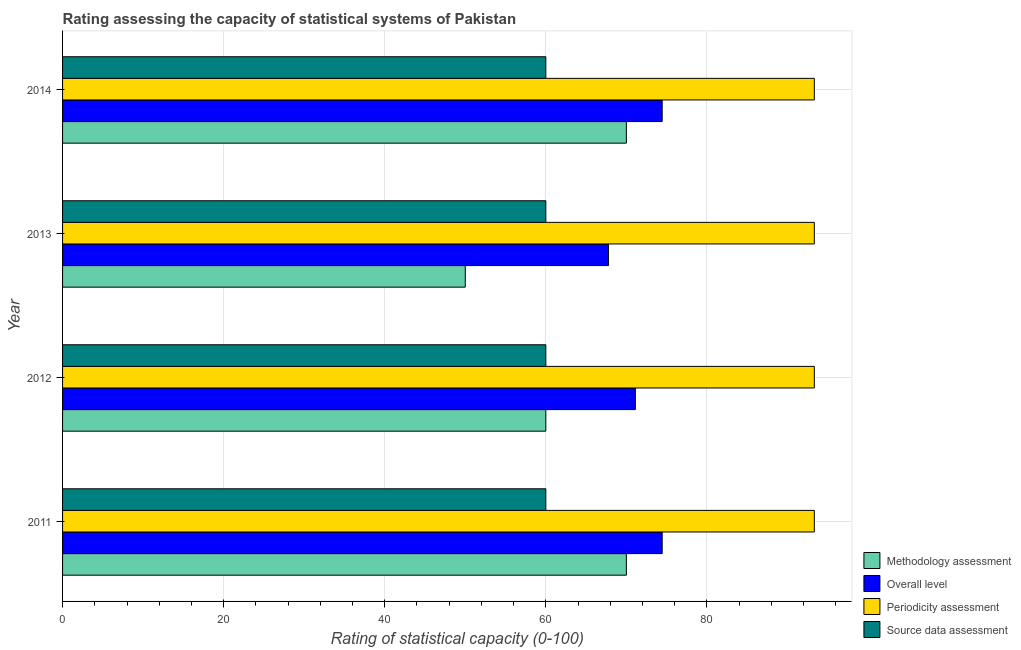How many bars are there on the 2nd tick from the top?
Provide a short and direct response. 4. In how many cases, is the number of bars for a given year not equal to the number of legend labels?
Give a very brief answer. 0. What is the source data assessment rating in 2012?
Offer a terse response. 60. Across all years, what is the maximum source data assessment rating?
Provide a succinct answer. 60. Across all years, what is the minimum periodicity assessment rating?
Your response must be concise. 93.33. In which year was the methodology assessment rating maximum?
Ensure brevity in your answer.  2011. In which year was the methodology assessment rating minimum?
Give a very brief answer. 2013. What is the total source data assessment rating in the graph?
Ensure brevity in your answer.  240. What is the difference between the overall level rating in 2013 and that in 2014?
Ensure brevity in your answer.  -6.67. What is the difference between the periodicity assessment rating in 2012 and the methodology assessment rating in 2014?
Your response must be concise. 23.33. What is the average overall level rating per year?
Keep it short and to the point. 71.94. In the year 2013, what is the difference between the overall level rating and methodology assessment rating?
Make the answer very short. 17.78. What is the ratio of the periodicity assessment rating in 2011 to that in 2013?
Your answer should be very brief. 1. Is the periodicity assessment rating in 2011 less than that in 2012?
Your answer should be very brief. No. What is the difference between the highest and the second highest methodology assessment rating?
Make the answer very short. 0. What is the difference between the highest and the lowest methodology assessment rating?
Your answer should be very brief. 20. In how many years, is the periodicity assessment rating greater than the average periodicity assessment rating taken over all years?
Your answer should be very brief. 2. Is the sum of the periodicity assessment rating in 2011 and 2013 greater than the maximum methodology assessment rating across all years?
Give a very brief answer. Yes. What does the 1st bar from the top in 2011 represents?
Give a very brief answer. Source data assessment. What does the 4th bar from the bottom in 2012 represents?
Your answer should be compact. Source data assessment. How many bars are there?
Provide a succinct answer. 16. How many years are there in the graph?
Your answer should be compact. 4. Are the values on the major ticks of X-axis written in scientific E-notation?
Ensure brevity in your answer.  No. Does the graph contain any zero values?
Ensure brevity in your answer.  No. Where does the legend appear in the graph?
Your response must be concise. Bottom right. What is the title of the graph?
Give a very brief answer. Rating assessing the capacity of statistical systems of Pakistan. Does "Labor Taxes" appear as one of the legend labels in the graph?
Provide a short and direct response. No. What is the label or title of the X-axis?
Your response must be concise. Rating of statistical capacity (0-100). What is the Rating of statistical capacity (0-100) in Overall level in 2011?
Your answer should be very brief. 74.44. What is the Rating of statistical capacity (0-100) in Periodicity assessment in 2011?
Provide a short and direct response. 93.33. What is the Rating of statistical capacity (0-100) of Methodology assessment in 2012?
Make the answer very short. 60. What is the Rating of statistical capacity (0-100) in Overall level in 2012?
Give a very brief answer. 71.11. What is the Rating of statistical capacity (0-100) of Periodicity assessment in 2012?
Offer a very short reply. 93.33. What is the Rating of statistical capacity (0-100) in Overall level in 2013?
Your answer should be very brief. 67.78. What is the Rating of statistical capacity (0-100) of Periodicity assessment in 2013?
Keep it short and to the point. 93.33. What is the Rating of statistical capacity (0-100) in Overall level in 2014?
Your response must be concise. 74.44. What is the Rating of statistical capacity (0-100) in Periodicity assessment in 2014?
Provide a short and direct response. 93.33. Across all years, what is the maximum Rating of statistical capacity (0-100) of Methodology assessment?
Provide a succinct answer. 70. Across all years, what is the maximum Rating of statistical capacity (0-100) in Overall level?
Give a very brief answer. 74.44. Across all years, what is the maximum Rating of statistical capacity (0-100) of Periodicity assessment?
Your response must be concise. 93.33. Across all years, what is the minimum Rating of statistical capacity (0-100) in Overall level?
Provide a short and direct response. 67.78. Across all years, what is the minimum Rating of statistical capacity (0-100) in Periodicity assessment?
Make the answer very short. 93.33. What is the total Rating of statistical capacity (0-100) of Methodology assessment in the graph?
Your response must be concise. 250. What is the total Rating of statistical capacity (0-100) in Overall level in the graph?
Keep it short and to the point. 287.78. What is the total Rating of statistical capacity (0-100) of Periodicity assessment in the graph?
Give a very brief answer. 373.33. What is the total Rating of statistical capacity (0-100) in Source data assessment in the graph?
Make the answer very short. 240. What is the difference between the Rating of statistical capacity (0-100) of Overall level in 2011 and that in 2013?
Make the answer very short. 6.67. What is the difference between the Rating of statistical capacity (0-100) in Periodicity assessment in 2011 and that in 2013?
Your response must be concise. -0. What is the difference between the Rating of statistical capacity (0-100) in Methodology assessment in 2011 and that in 2014?
Ensure brevity in your answer.  0. What is the difference between the Rating of statistical capacity (0-100) of Overall level in 2011 and that in 2014?
Offer a very short reply. 0. What is the difference between the Rating of statistical capacity (0-100) in Periodicity assessment in 2011 and that in 2014?
Provide a short and direct response. -0. What is the difference between the Rating of statistical capacity (0-100) in Source data assessment in 2012 and that in 2013?
Keep it short and to the point. 0. What is the difference between the Rating of statistical capacity (0-100) in Methodology assessment in 2012 and that in 2014?
Keep it short and to the point. -10. What is the difference between the Rating of statistical capacity (0-100) in Overall level in 2012 and that in 2014?
Offer a terse response. -3.33. What is the difference between the Rating of statistical capacity (0-100) in Periodicity assessment in 2012 and that in 2014?
Make the answer very short. -0. What is the difference between the Rating of statistical capacity (0-100) in Overall level in 2013 and that in 2014?
Offer a very short reply. -6.67. What is the difference between the Rating of statistical capacity (0-100) of Methodology assessment in 2011 and the Rating of statistical capacity (0-100) of Overall level in 2012?
Offer a very short reply. -1.11. What is the difference between the Rating of statistical capacity (0-100) in Methodology assessment in 2011 and the Rating of statistical capacity (0-100) in Periodicity assessment in 2012?
Provide a succinct answer. -23.33. What is the difference between the Rating of statistical capacity (0-100) in Methodology assessment in 2011 and the Rating of statistical capacity (0-100) in Source data assessment in 2012?
Keep it short and to the point. 10. What is the difference between the Rating of statistical capacity (0-100) of Overall level in 2011 and the Rating of statistical capacity (0-100) of Periodicity assessment in 2012?
Ensure brevity in your answer.  -18.89. What is the difference between the Rating of statistical capacity (0-100) in Overall level in 2011 and the Rating of statistical capacity (0-100) in Source data assessment in 2012?
Ensure brevity in your answer.  14.44. What is the difference between the Rating of statistical capacity (0-100) of Periodicity assessment in 2011 and the Rating of statistical capacity (0-100) of Source data assessment in 2012?
Ensure brevity in your answer.  33.33. What is the difference between the Rating of statistical capacity (0-100) in Methodology assessment in 2011 and the Rating of statistical capacity (0-100) in Overall level in 2013?
Provide a succinct answer. 2.22. What is the difference between the Rating of statistical capacity (0-100) of Methodology assessment in 2011 and the Rating of statistical capacity (0-100) of Periodicity assessment in 2013?
Ensure brevity in your answer.  -23.33. What is the difference between the Rating of statistical capacity (0-100) in Overall level in 2011 and the Rating of statistical capacity (0-100) in Periodicity assessment in 2013?
Give a very brief answer. -18.89. What is the difference between the Rating of statistical capacity (0-100) in Overall level in 2011 and the Rating of statistical capacity (0-100) in Source data assessment in 2013?
Your answer should be compact. 14.44. What is the difference between the Rating of statistical capacity (0-100) of Periodicity assessment in 2011 and the Rating of statistical capacity (0-100) of Source data assessment in 2013?
Your answer should be compact. 33.33. What is the difference between the Rating of statistical capacity (0-100) in Methodology assessment in 2011 and the Rating of statistical capacity (0-100) in Overall level in 2014?
Offer a very short reply. -4.44. What is the difference between the Rating of statistical capacity (0-100) in Methodology assessment in 2011 and the Rating of statistical capacity (0-100) in Periodicity assessment in 2014?
Make the answer very short. -23.33. What is the difference between the Rating of statistical capacity (0-100) of Overall level in 2011 and the Rating of statistical capacity (0-100) of Periodicity assessment in 2014?
Your answer should be very brief. -18.89. What is the difference between the Rating of statistical capacity (0-100) of Overall level in 2011 and the Rating of statistical capacity (0-100) of Source data assessment in 2014?
Offer a terse response. 14.44. What is the difference between the Rating of statistical capacity (0-100) of Periodicity assessment in 2011 and the Rating of statistical capacity (0-100) of Source data assessment in 2014?
Your answer should be compact. 33.33. What is the difference between the Rating of statistical capacity (0-100) of Methodology assessment in 2012 and the Rating of statistical capacity (0-100) of Overall level in 2013?
Provide a succinct answer. -7.78. What is the difference between the Rating of statistical capacity (0-100) in Methodology assessment in 2012 and the Rating of statistical capacity (0-100) in Periodicity assessment in 2013?
Ensure brevity in your answer.  -33.33. What is the difference between the Rating of statistical capacity (0-100) of Overall level in 2012 and the Rating of statistical capacity (0-100) of Periodicity assessment in 2013?
Your answer should be very brief. -22.22. What is the difference between the Rating of statistical capacity (0-100) in Overall level in 2012 and the Rating of statistical capacity (0-100) in Source data assessment in 2013?
Keep it short and to the point. 11.11. What is the difference between the Rating of statistical capacity (0-100) of Periodicity assessment in 2012 and the Rating of statistical capacity (0-100) of Source data assessment in 2013?
Give a very brief answer. 33.33. What is the difference between the Rating of statistical capacity (0-100) in Methodology assessment in 2012 and the Rating of statistical capacity (0-100) in Overall level in 2014?
Provide a short and direct response. -14.44. What is the difference between the Rating of statistical capacity (0-100) of Methodology assessment in 2012 and the Rating of statistical capacity (0-100) of Periodicity assessment in 2014?
Your response must be concise. -33.33. What is the difference between the Rating of statistical capacity (0-100) in Overall level in 2012 and the Rating of statistical capacity (0-100) in Periodicity assessment in 2014?
Provide a short and direct response. -22.22. What is the difference between the Rating of statistical capacity (0-100) in Overall level in 2012 and the Rating of statistical capacity (0-100) in Source data assessment in 2014?
Provide a short and direct response. 11.11. What is the difference between the Rating of statistical capacity (0-100) of Periodicity assessment in 2012 and the Rating of statistical capacity (0-100) of Source data assessment in 2014?
Your answer should be compact. 33.33. What is the difference between the Rating of statistical capacity (0-100) of Methodology assessment in 2013 and the Rating of statistical capacity (0-100) of Overall level in 2014?
Offer a very short reply. -24.44. What is the difference between the Rating of statistical capacity (0-100) of Methodology assessment in 2013 and the Rating of statistical capacity (0-100) of Periodicity assessment in 2014?
Give a very brief answer. -43.33. What is the difference between the Rating of statistical capacity (0-100) in Overall level in 2013 and the Rating of statistical capacity (0-100) in Periodicity assessment in 2014?
Give a very brief answer. -25.56. What is the difference between the Rating of statistical capacity (0-100) in Overall level in 2013 and the Rating of statistical capacity (0-100) in Source data assessment in 2014?
Your answer should be very brief. 7.78. What is the difference between the Rating of statistical capacity (0-100) in Periodicity assessment in 2013 and the Rating of statistical capacity (0-100) in Source data assessment in 2014?
Make the answer very short. 33.33. What is the average Rating of statistical capacity (0-100) in Methodology assessment per year?
Give a very brief answer. 62.5. What is the average Rating of statistical capacity (0-100) of Overall level per year?
Ensure brevity in your answer.  71.94. What is the average Rating of statistical capacity (0-100) in Periodicity assessment per year?
Your answer should be very brief. 93.33. What is the average Rating of statistical capacity (0-100) of Source data assessment per year?
Provide a short and direct response. 60. In the year 2011, what is the difference between the Rating of statistical capacity (0-100) in Methodology assessment and Rating of statistical capacity (0-100) in Overall level?
Your answer should be compact. -4.44. In the year 2011, what is the difference between the Rating of statistical capacity (0-100) of Methodology assessment and Rating of statistical capacity (0-100) of Periodicity assessment?
Your response must be concise. -23.33. In the year 2011, what is the difference between the Rating of statistical capacity (0-100) in Methodology assessment and Rating of statistical capacity (0-100) in Source data assessment?
Your answer should be very brief. 10. In the year 2011, what is the difference between the Rating of statistical capacity (0-100) of Overall level and Rating of statistical capacity (0-100) of Periodicity assessment?
Offer a terse response. -18.89. In the year 2011, what is the difference between the Rating of statistical capacity (0-100) of Overall level and Rating of statistical capacity (0-100) of Source data assessment?
Your response must be concise. 14.44. In the year 2011, what is the difference between the Rating of statistical capacity (0-100) of Periodicity assessment and Rating of statistical capacity (0-100) of Source data assessment?
Provide a succinct answer. 33.33. In the year 2012, what is the difference between the Rating of statistical capacity (0-100) of Methodology assessment and Rating of statistical capacity (0-100) of Overall level?
Make the answer very short. -11.11. In the year 2012, what is the difference between the Rating of statistical capacity (0-100) in Methodology assessment and Rating of statistical capacity (0-100) in Periodicity assessment?
Give a very brief answer. -33.33. In the year 2012, what is the difference between the Rating of statistical capacity (0-100) in Overall level and Rating of statistical capacity (0-100) in Periodicity assessment?
Keep it short and to the point. -22.22. In the year 2012, what is the difference between the Rating of statistical capacity (0-100) in Overall level and Rating of statistical capacity (0-100) in Source data assessment?
Your response must be concise. 11.11. In the year 2012, what is the difference between the Rating of statistical capacity (0-100) of Periodicity assessment and Rating of statistical capacity (0-100) of Source data assessment?
Keep it short and to the point. 33.33. In the year 2013, what is the difference between the Rating of statistical capacity (0-100) in Methodology assessment and Rating of statistical capacity (0-100) in Overall level?
Give a very brief answer. -17.78. In the year 2013, what is the difference between the Rating of statistical capacity (0-100) in Methodology assessment and Rating of statistical capacity (0-100) in Periodicity assessment?
Keep it short and to the point. -43.33. In the year 2013, what is the difference between the Rating of statistical capacity (0-100) of Overall level and Rating of statistical capacity (0-100) of Periodicity assessment?
Provide a short and direct response. -25.56. In the year 2013, what is the difference between the Rating of statistical capacity (0-100) in Overall level and Rating of statistical capacity (0-100) in Source data assessment?
Your answer should be compact. 7.78. In the year 2013, what is the difference between the Rating of statistical capacity (0-100) of Periodicity assessment and Rating of statistical capacity (0-100) of Source data assessment?
Offer a terse response. 33.33. In the year 2014, what is the difference between the Rating of statistical capacity (0-100) in Methodology assessment and Rating of statistical capacity (0-100) in Overall level?
Your answer should be very brief. -4.44. In the year 2014, what is the difference between the Rating of statistical capacity (0-100) in Methodology assessment and Rating of statistical capacity (0-100) in Periodicity assessment?
Ensure brevity in your answer.  -23.33. In the year 2014, what is the difference between the Rating of statistical capacity (0-100) of Overall level and Rating of statistical capacity (0-100) of Periodicity assessment?
Your response must be concise. -18.89. In the year 2014, what is the difference between the Rating of statistical capacity (0-100) in Overall level and Rating of statistical capacity (0-100) in Source data assessment?
Offer a terse response. 14.44. In the year 2014, what is the difference between the Rating of statistical capacity (0-100) in Periodicity assessment and Rating of statistical capacity (0-100) in Source data assessment?
Provide a short and direct response. 33.33. What is the ratio of the Rating of statistical capacity (0-100) of Overall level in 2011 to that in 2012?
Your answer should be very brief. 1.05. What is the ratio of the Rating of statistical capacity (0-100) in Periodicity assessment in 2011 to that in 2012?
Ensure brevity in your answer.  1. What is the ratio of the Rating of statistical capacity (0-100) of Source data assessment in 2011 to that in 2012?
Make the answer very short. 1. What is the ratio of the Rating of statistical capacity (0-100) in Methodology assessment in 2011 to that in 2013?
Provide a short and direct response. 1.4. What is the ratio of the Rating of statistical capacity (0-100) in Overall level in 2011 to that in 2013?
Provide a succinct answer. 1.1. What is the ratio of the Rating of statistical capacity (0-100) of Periodicity assessment in 2011 to that in 2013?
Provide a short and direct response. 1. What is the ratio of the Rating of statistical capacity (0-100) of Source data assessment in 2011 to that in 2013?
Offer a terse response. 1. What is the ratio of the Rating of statistical capacity (0-100) of Methodology assessment in 2011 to that in 2014?
Provide a succinct answer. 1. What is the ratio of the Rating of statistical capacity (0-100) of Source data assessment in 2011 to that in 2014?
Offer a terse response. 1. What is the ratio of the Rating of statistical capacity (0-100) in Methodology assessment in 2012 to that in 2013?
Give a very brief answer. 1.2. What is the ratio of the Rating of statistical capacity (0-100) of Overall level in 2012 to that in 2013?
Your answer should be very brief. 1.05. What is the ratio of the Rating of statistical capacity (0-100) of Methodology assessment in 2012 to that in 2014?
Offer a very short reply. 0.86. What is the ratio of the Rating of statistical capacity (0-100) of Overall level in 2012 to that in 2014?
Keep it short and to the point. 0.96. What is the ratio of the Rating of statistical capacity (0-100) in Source data assessment in 2012 to that in 2014?
Offer a terse response. 1. What is the ratio of the Rating of statistical capacity (0-100) in Overall level in 2013 to that in 2014?
Provide a short and direct response. 0.91. What is the ratio of the Rating of statistical capacity (0-100) in Periodicity assessment in 2013 to that in 2014?
Provide a succinct answer. 1. What is the ratio of the Rating of statistical capacity (0-100) of Source data assessment in 2013 to that in 2014?
Make the answer very short. 1. What is the difference between the highest and the second highest Rating of statistical capacity (0-100) of Overall level?
Provide a short and direct response. 0. What is the difference between the highest and the second highest Rating of statistical capacity (0-100) of Source data assessment?
Make the answer very short. 0. What is the difference between the highest and the lowest Rating of statistical capacity (0-100) in Methodology assessment?
Offer a terse response. 20. 